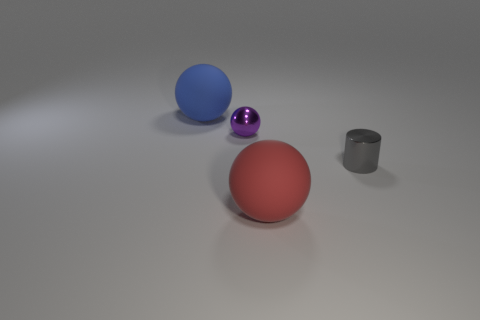Add 4 purple objects. How many objects exist? 8 Subtract all large rubber spheres. How many spheres are left? 1 Subtract all cylinders. How many objects are left? 3 Subtract 0 cyan balls. How many objects are left? 4 Subtract all cyan balls. Subtract all gray blocks. How many balls are left? 3 Subtract all small cylinders. Subtract all tiny brown metal cubes. How many objects are left? 3 Add 2 small metal objects. How many small metal objects are left? 4 Add 4 purple things. How many purple things exist? 5 